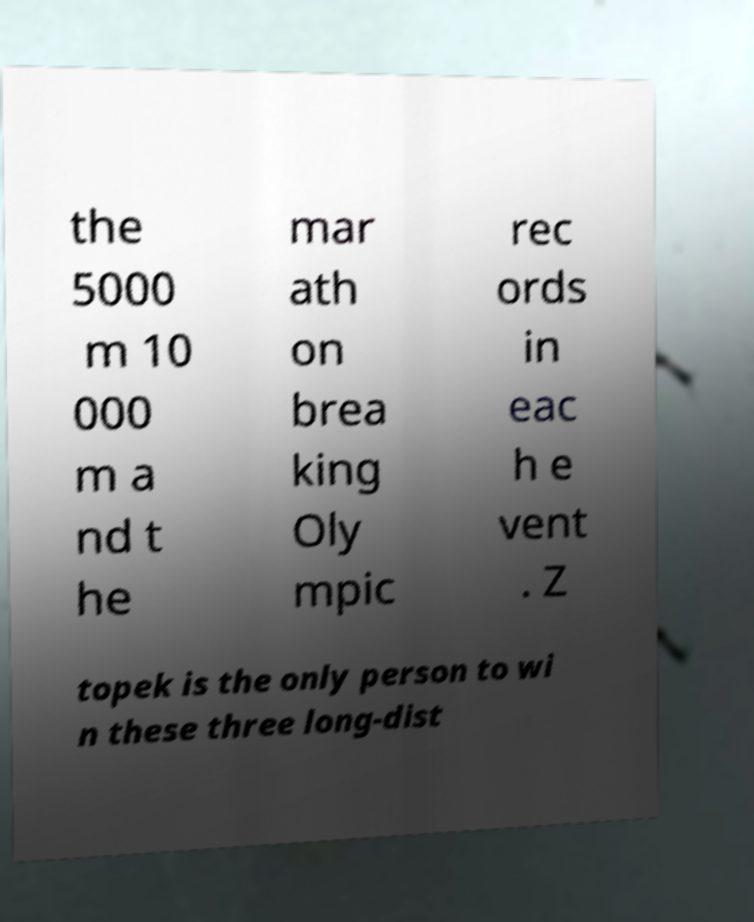Could you assist in decoding the text presented in this image and type it out clearly? the 5000 m 10 000 m a nd t he mar ath on brea king Oly mpic rec ords in eac h e vent . Z topek is the only person to wi n these three long-dist 